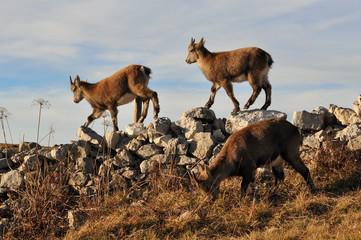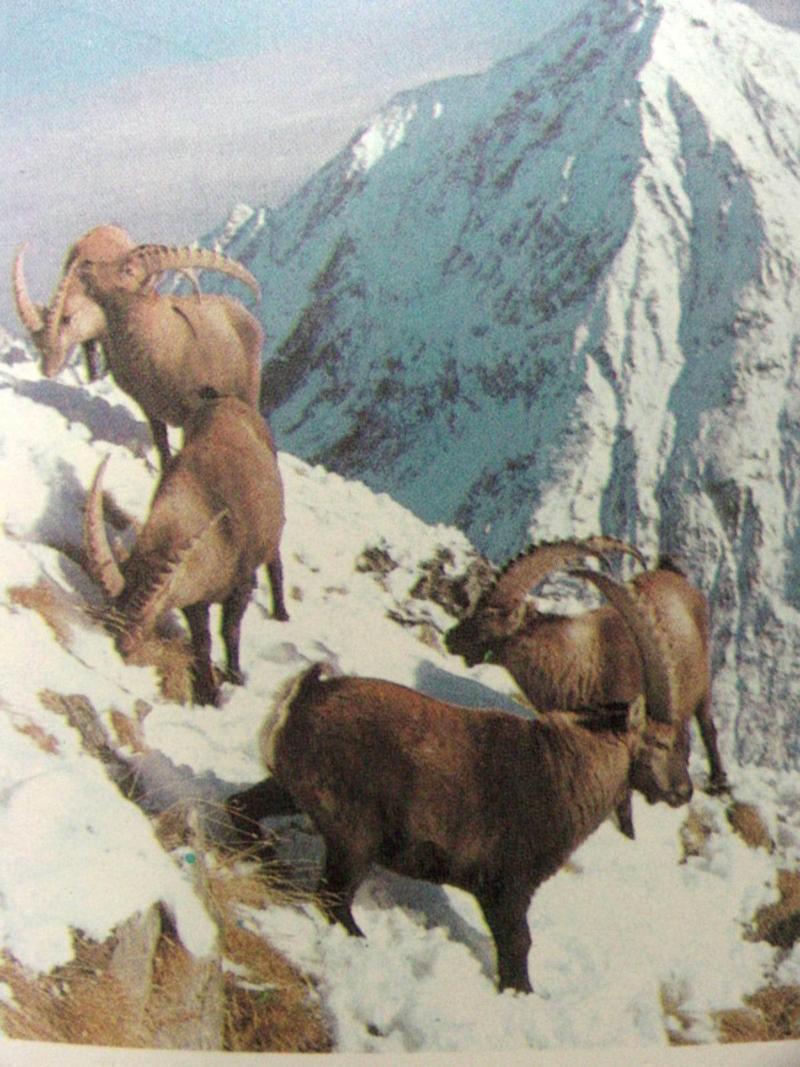The first image is the image on the left, the second image is the image on the right. Given the left and right images, does the statement "Two cloven animals are nudging each other with their heads." hold true? Answer yes or no. No. The first image is the image on the left, the second image is the image on the right. Analyze the images presented: Is the assertion "The image to the left contains more than one goat." valid? Answer yes or no. Yes. 